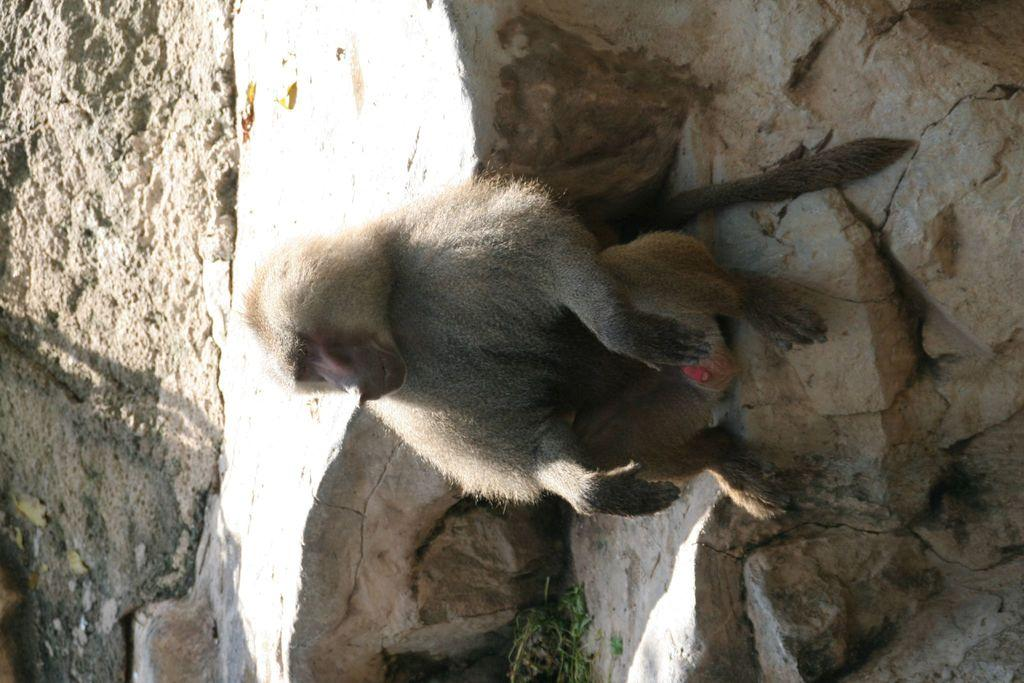What animal is present in the image? There is a monkey in the image. What is the monkey sitting on? The monkey is sitting on rocks. Can you see a tiger in the image? No, there is no tiger present in the image; it only features a monkey sitting on rocks. Is there a zipper visible on the monkey's clothing? There is no clothing or zipper mentioned in the image, as it only features a monkey sitting on rocks. 